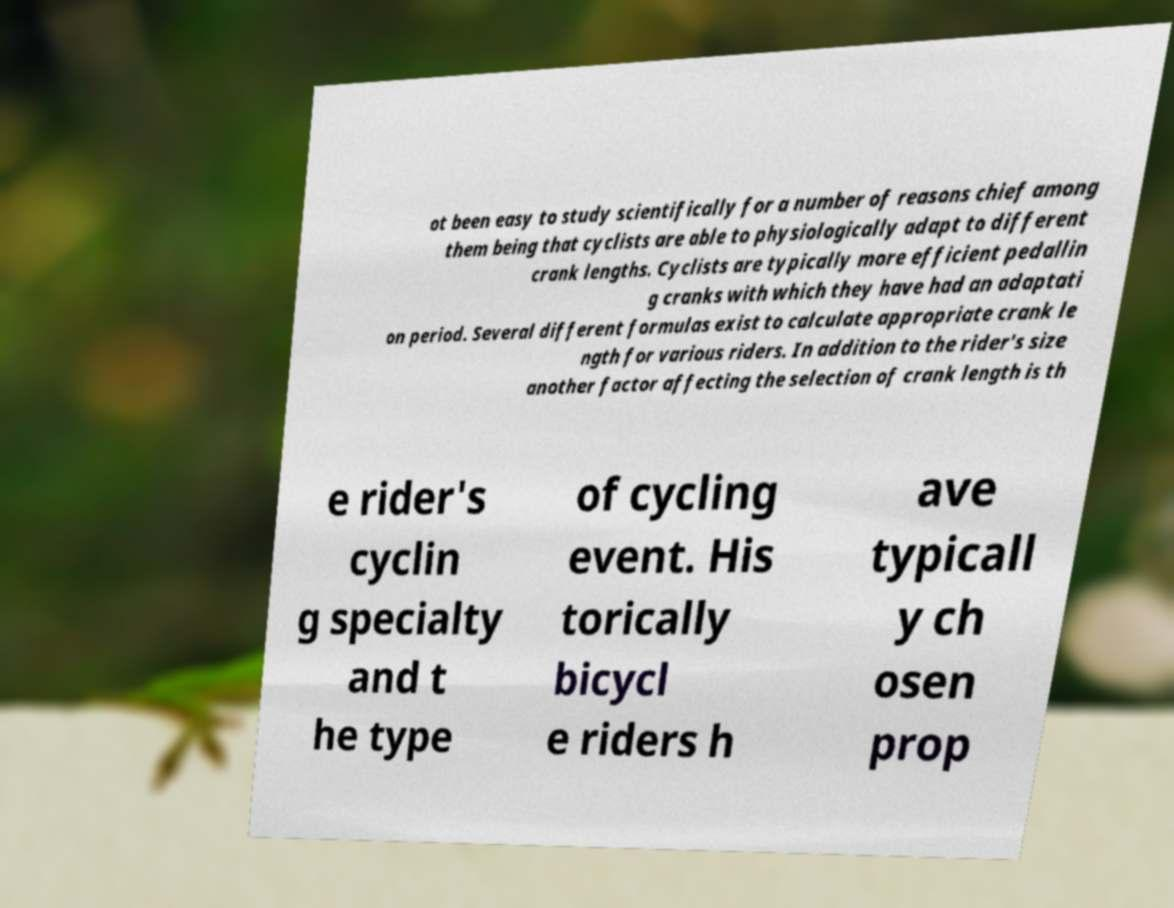Can you accurately transcribe the text from the provided image for me? ot been easy to study scientifically for a number of reasons chief among them being that cyclists are able to physiologically adapt to different crank lengths. Cyclists are typically more efficient pedallin g cranks with which they have had an adaptati on period. Several different formulas exist to calculate appropriate crank le ngth for various riders. In addition to the rider's size another factor affecting the selection of crank length is th e rider's cyclin g specialty and t he type of cycling event. His torically bicycl e riders h ave typicall y ch osen prop 